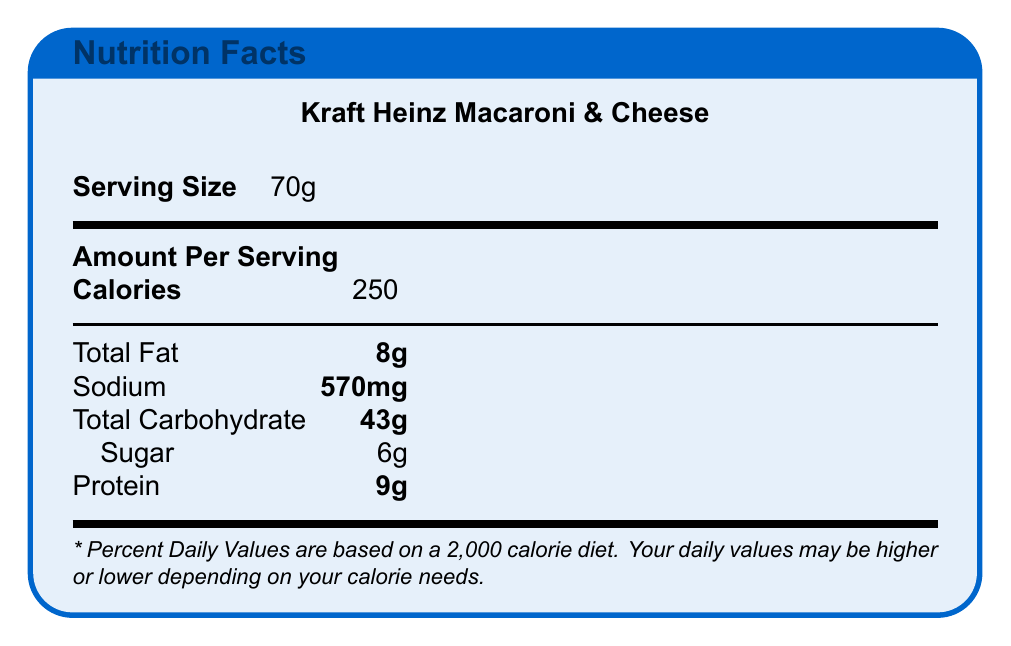what is the serving size for Kraft Heinz Macaroni & Cheese? The document specifies that the serving size for Kraft Heinz Macaroni & Cheese is 70g.
Answer: 70g What is the sodium content per serving of Kraft Heinz Macaroni & Cheese? The Nutrition Facts section of the document lists sodium content as 570mg per serving.
Answer: 570mg What is the total carbohydrate content in a serving of Kraft Heinz Macaroni & Cheese? The document states that the total carbohydrate content in a serving of Kraft Heinz Macaroni & Cheese is 43g.
Answer: 43g How much sugar is in a single serving of Kraft Heinz Macaroni & Cheese? The Nutrition Facts indicate that there is 6g of sugar in a serving of Kraft Heinz Macaroni & Cheese.
Answer: 6g What is the protein content found in a serving of Kraft Heinz Macaroni & Cheese? The document shows that the protein content in a serving is 9g.
Answer: 9g Which of the following is accurate about the total fat content in Kraft Heinz Macaroni & Cheese? A. 5g B. 8g C. 10g D. 12g The document specifies that the total fat content is 8g per serving.
Answer: B How many calories are there per serving in Kraft Heinz Macaroni & Cheese? A. 200 B. 250 C. 300 D. 400 The document lists the calorie amount per serving as 250.
Answer: B Is the sodium content in a serving of Kraft Heinz Macaroni & Cheese higher than 500mg? The document states that the sodium content per serving is 570mg, which is higher than 500mg.
Answer: Yes Summarize the main points of the document The summary of the document highlights that it provides specific nutritional information about Kraft Heinz Macaroni & Cheese, detailing the serving size, calories, and various nutrient contents.
Answer: The document provides the Nutrition Facts for Kraft Heinz Macaroni & Cheese, including serving size, calorie count, and amounts of total fat, sodium, carbohydrates (with sugar as a subcategory), and protein. What are the economic impacts of stricter sodium regulations on Kraft Heinz? The document does not provide economic impact details or link them directly to Kraft Heinz's Macaroni & Cheese product.
Answer: Not enough information How do the sodium levels in Kraft Heinz Macaroni & Cheese compare to Campbell's Chunky Classic Chicken Noodle Soup? The sodium content for Kraft Heinz Macaroni & Cheese is 570mg per serving, while Campbell's Chunky Classic Chicken Noodle Soup has 890mg per serving.
Answer: Kraft Heinz Macaroni & Cheese has 570mg, Campbell's has 890mg 